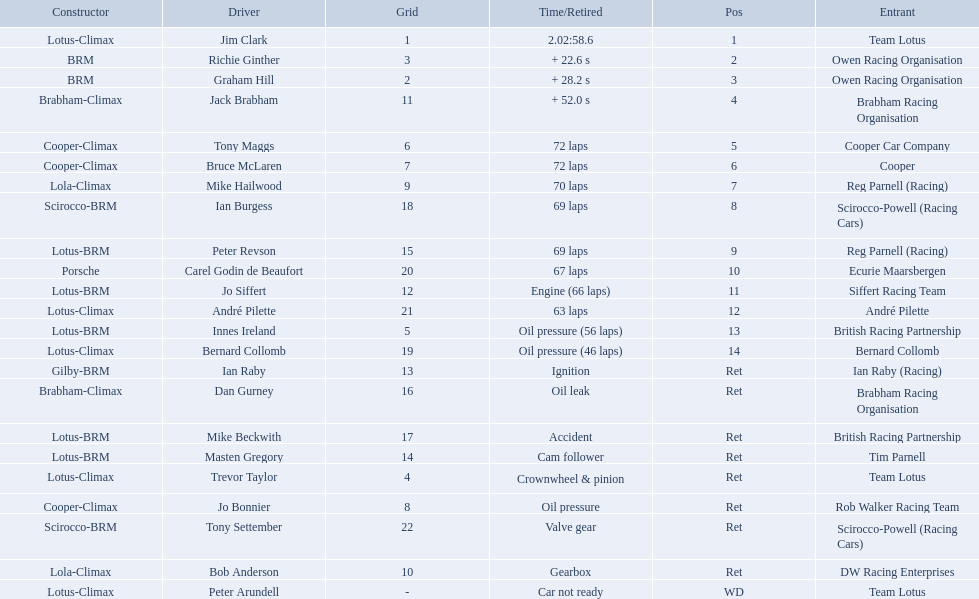Who were the drivers at the 1963 international gold cup? Jim Clark, Richie Ginther, Graham Hill, Jack Brabham, Tony Maggs, Bruce McLaren, Mike Hailwood, Ian Burgess, Peter Revson, Carel Godin de Beaufort, Jo Siffert, André Pilette, Innes Ireland, Bernard Collomb, Ian Raby, Dan Gurney, Mike Beckwith, Masten Gregory, Trevor Taylor, Jo Bonnier, Tony Settember, Bob Anderson, Peter Arundell. What was tony maggs position? 5. What was jo siffert? 11. Who came in earlier? Tony Maggs. 